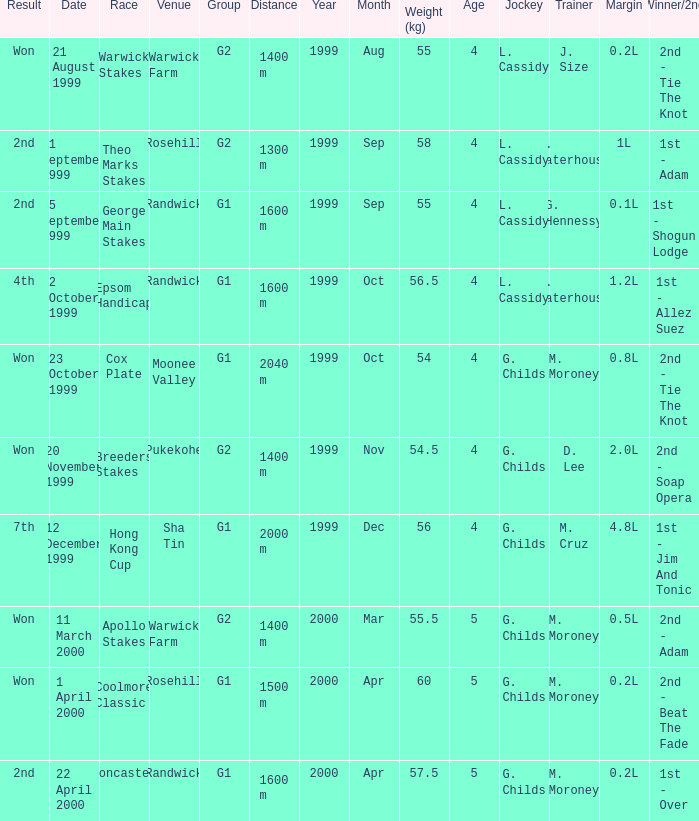Parse the table in full. {'header': ['Result', 'Date', 'Race', 'Venue', 'Group', 'Distance', 'Year', 'Month', 'Weight (kg)', 'Age', 'Jockey', 'Trainer', 'Margin', 'Winner/2nd'], 'rows': [['Won', '21 August 1999', 'Warwick Stakes', 'Warwick Farm', 'G2', '1400 m', '1999', 'Aug', '55', '4', 'L. Cassidy', 'J. Size', '0.2L', '2nd - Tie The Knot'], ['2nd', '11 September 1999', 'Theo Marks Stakes', 'Rosehill', 'G2', '1300 m', '1999', 'Sep', '58', '4', 'L. Cassidy', 'G. Waterhouse', '1L', '1st - Adam'], ['2nd', '25 September 1999', 'George Main Stakes', 'Randwick', 'G1', '1600 m', '1999', 'Sep', '55', '4', 'L. Cassidy', 'G. Hennessy', '0.1L', '1st - Shogun Lodge'], ['4th', '2 October 1999', 'Epsom Handicap', 'Randwick', 'G1', '1600 m', '1999', 'Oct', '56.5', '4', 'L. Cassidy', 'G. Waterhouse', '1.2L', '1st - Allez Suez'], ['Won', '23 October 1999', 'Cox Plate', 'Moonee Valley', 'G1', '2040 m', '1999', 'Oct', '54', '4', 'G. Childs', 'M. Moroney', '0.8L', '2nd - Tie The Knot'], ['Won', '20 November 1999', 'Breeders Stakes', 'Pukekohe', 'G2', '1400 m', '1999', 'Nov', '54.5', '4', 'G. Childs', 'D. Lee', '2.0L', '2nd - Soap Opera'], ['7th', '12 December 1999', 'Hong Kong Cup', 'Sha Tin', 'G1', '2000 m', '1999', 'Dec', '56', '4', 'G. Childs', 'M. Cruz', '4.8L', '1st - Jim And Tonic'], ['Won', '11 March 2000', 'Apollo Stakes', 'Warwick Farm', 'G2', '1400 m', '2000', 'Mar', '55.5', '5', 'G. Childs', 'M. Moroney', '0.5L', '2nd - Adam'], ['Won', '1 April 2000', 'Coolmore Classic', 'Rosehill', 'G1', '1500 m', '2000', 'Apr', '60', '5', 'G. Childs', 'M. Moroney', '0.2L', '2nd - Beat The Fade'], ['2nd', '22 April 2000', 'Doncaster', 'Randwick', 'G1', '1600 m', '2000', 'Apr', '57.5', '5', 'G. Childs', 'M. Moroney', '0.2L', '1st - Over']]} List the weight for 56 kilograms. 2000 m. 